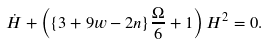<formula> <loc_0><loc_0><loc_500><loc_500>\dot { H } + \left ( \{ 3 + 9 w - 2 n \} \frac { \Omega } { 6 } + 1 \right ) H ^ { 2 } = 0 .</formula> 